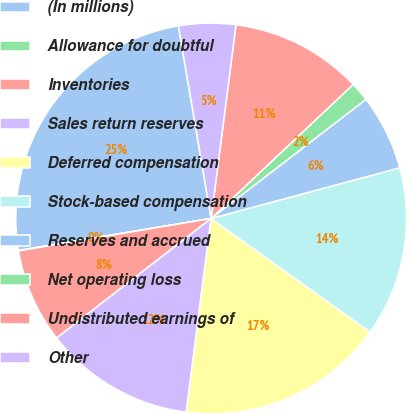<chart> <loc_0><loc_0><loc_500><loc_500><pie_chart><fcel>(In millions)<fcel>Allowance for doubtful<fcel>Inventories<fcel>Sales return reserves<fcel>Deferred compensation<fcel>Stock-based compensation<fcel>Reserves and accrued<fcel>Net operating loss<fcel>Undistributed earnings of<fcel>Other<nl><fcel>24.94%<fcel>0.04%<fcel>7.82%<fcel>12.49%<fcel>17.16%<fcel>14.05%<fcel>6.26%<fcel>1.6%<fcel>10.93%<fcel>4.71%<nl></chart> 